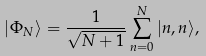Convert formula to latex. <formula><loc_0><loc_0><loc_500><loc_500>| \Phi _ { N } \rangle = \frac { 1 } { \sqrt { N + 1 } } \sum _ { n = 0 } ^ { N } | n , n \rangle ,</formula> 